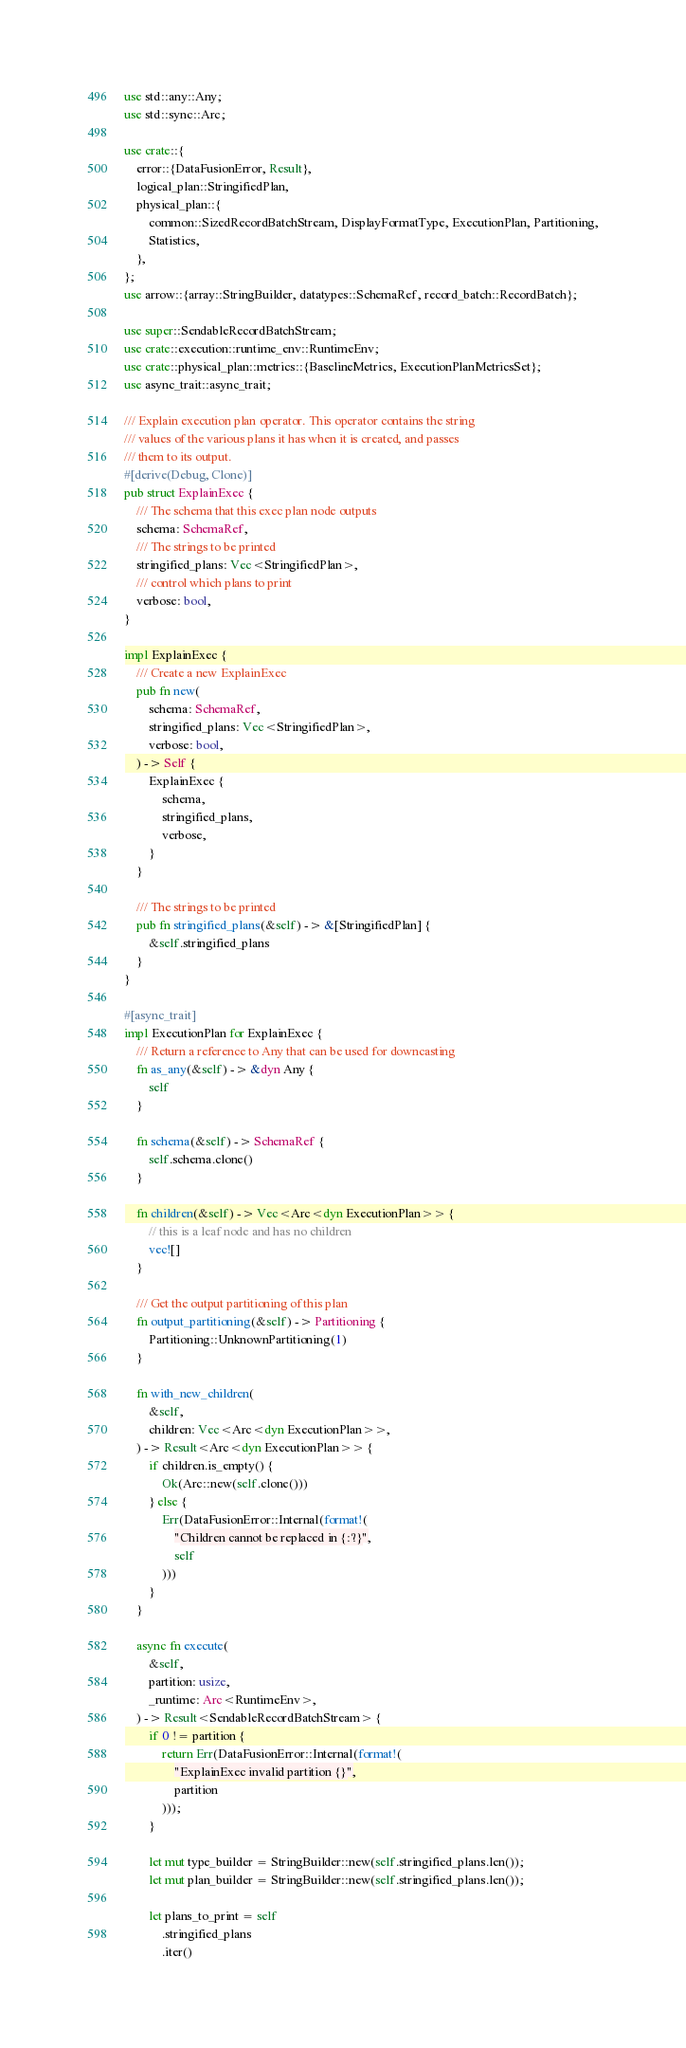<code> <loc_0><loc_0><loc_500><loc_500><_Rust_>
use std::any::Any;
use std::sync::Arc;

use crate::{
    error::{DataFusionError, Result},
    logical_plan::StringifiedPlan,
    physical_plan::{
        common::SizedRecordBatchStream, DisplayFormatType, ExecutionPlan, Partitioning,
        Statistics,
    },
};
use arrow::{array::StringBuilder, datatypes::SchemaRef, record_batch::RecordBatch};

use super::SendableRecordBatchStream;
use crate::execution::runtime_env::RuntimeEnv;
use crate::physical_plan::metrics::{BaselineMetrics, ExecutionPlanMetricsSet};
use async_trait::async_trait;

/// Explain execution plan operator. This operator contains the string
/// values of the various plans it has when it is created, and passes
/// them to its output.
#[derive(Debug, Clone)]
pub struct ExplainExec {
    /// The schema that this exec plan node outputs
    schema: SchemaRef,
    /// The strings to be printed
    stringified_plans: Vec<StringifiedPlan>,
    /// control which plans to print
    verbose: bool,
}

impl ExplainExec {
    /// Create a new ExplainExec
    pub fn new(
        schema: SchemaRef,
        stringified_plans: Vec<StringifiedPlan>,
        verbose: bool,
    ) -> Self {
        ExplainExec {
            schema,
            stringified_plans,
            verbose,
        }
    }

    /// The strings to be printed
    pub fn stringified_plans(&self) -> &[StringifiedPlan] {
        &self.stringified_plans
    }
}

#[async_trait]
impl ExecutionPlan for ExplainExec {
    /// Return a reference to Any that can be used for downcasting
    fn as_any(&self) -> &dyn Any {
        self
    }

    fn schema(&self) -> SchemaRef {
        self.schema.clone()
    }

    fn children(&self) -> Vec<Arc<dyn ExecutionPlan>> {
        // this is a leaf node and has no children
        vec![]
    }

    /// Get the output partitioning of this plan
    fn output_partitioning(&self) -> Partitioning {
        Partitioning::UnknownPartitioning(1)
    }

    fn with_new_children(
        &self,
        children: Vec<Arc<dyn ExecutionPlan>>,
    ) -> Result<Arc<dyn ExecutionPlan>> {
        if children.is_empty() {
            Ok(Arc::new(self.clone()))
        } else {
            Err(DataFusionError::Internal(format!(
                "Children cannot be replaced in {:?}",
                self
            )))
        }
    }

    async fn execute(
        &self,
        partition: usize,
        _runtime: Arc<RuntimeEnv>,
    ) -> Result<SendableRecordBatchStream> {
        if 0 != partition {
            return Err(DataFusionError::Internal(format!(
                "ExplainExec invalid partition {}",
                partition
            )));
        }

        let mut type_builder = StringBuilder::new(self.stringified_plans.len());
        let mut plan_builder = StringBuilder::new(self.stringified_plans.len());

        let plans_to_print = self
            .stringified_plans
            .iter()</code> 